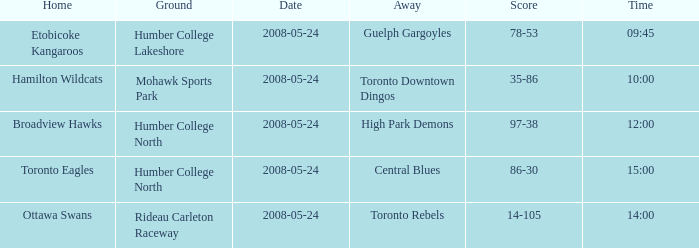Who was the home team of the game at the time of 15:00? Toronto Eagles. 